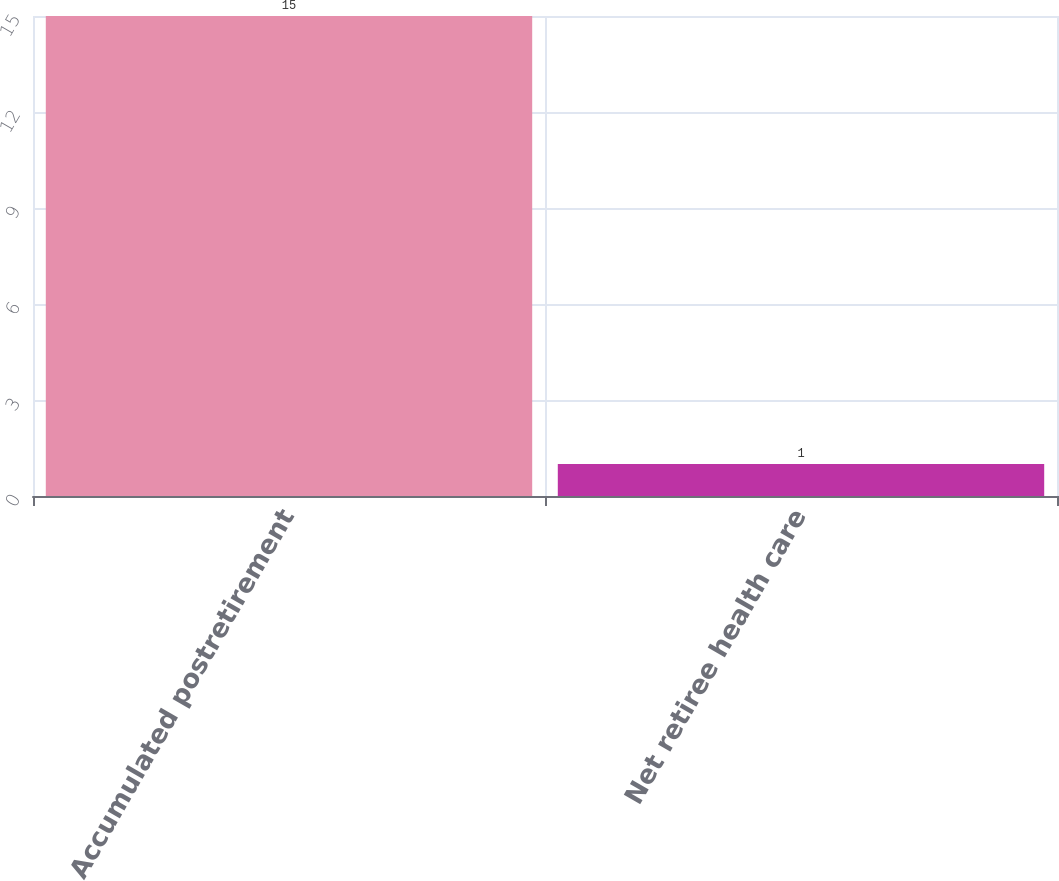Convert chart to OTSL. <chart><loc_0><loc_0><loc_500><loc_500><bar_chart><fcel>Accumulated postretirement<fcel>Net retiree health care<nl><fcel>15<fcel>1<nl></chart> 